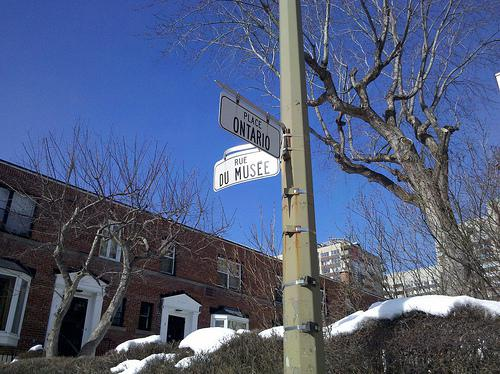Question: what color is the sky?
Choices:
A. Blue.
B. Dark blue.
C. Orange.
D. Magenta.
Answer with the letter. Answer: A Question: how many doors are visible?
Choices:
A. Two.
B. Three.
C. Four.
D. Five.
Answer with the letter. Answer: A Question: when was the photo taken?
Choices:
A. Yesterday.
B. At midnight.
C. Noon.
D. In the winter.
Answer with the letter. Answer: D Question: what is on top of the shrubs?
Choices:
A. Flowers.
B. Water.
C. Dust.
D. Snow.
Answer with the letter. Answer: D Question: what is on the pole?
Choices:
A. Stop sign.
B. Some shoes.
C. A billboard.
D. Street signs.
Answer with the letter. Answer: D 